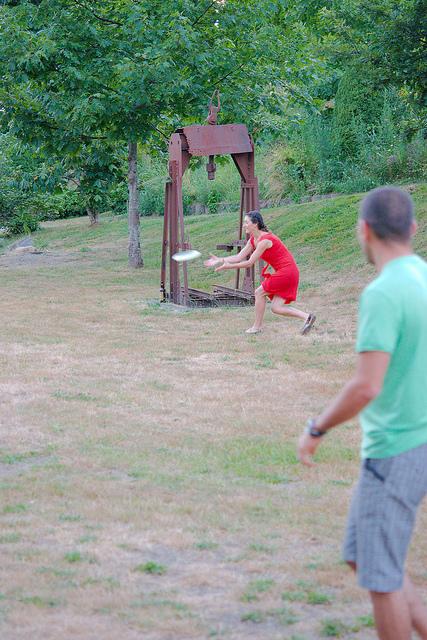How many people are in the shot?
Write a very short answer. 2. What is she catching?
Short answer required. Frisbee. Is the man wearing pants?
Concise answer only. No. How many people are in the picture?
Quick response, please. 2. What is the woman doing?
Be succinct. Frisbee. Who is wearing a watch?
Keep it brief. Man. What type of outfit is the woman wearing?
Short answer required. Dress. 